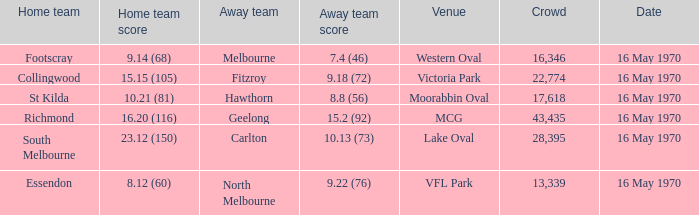What's the venue for the home team that scored 9.14 (68)? Western Oval. 